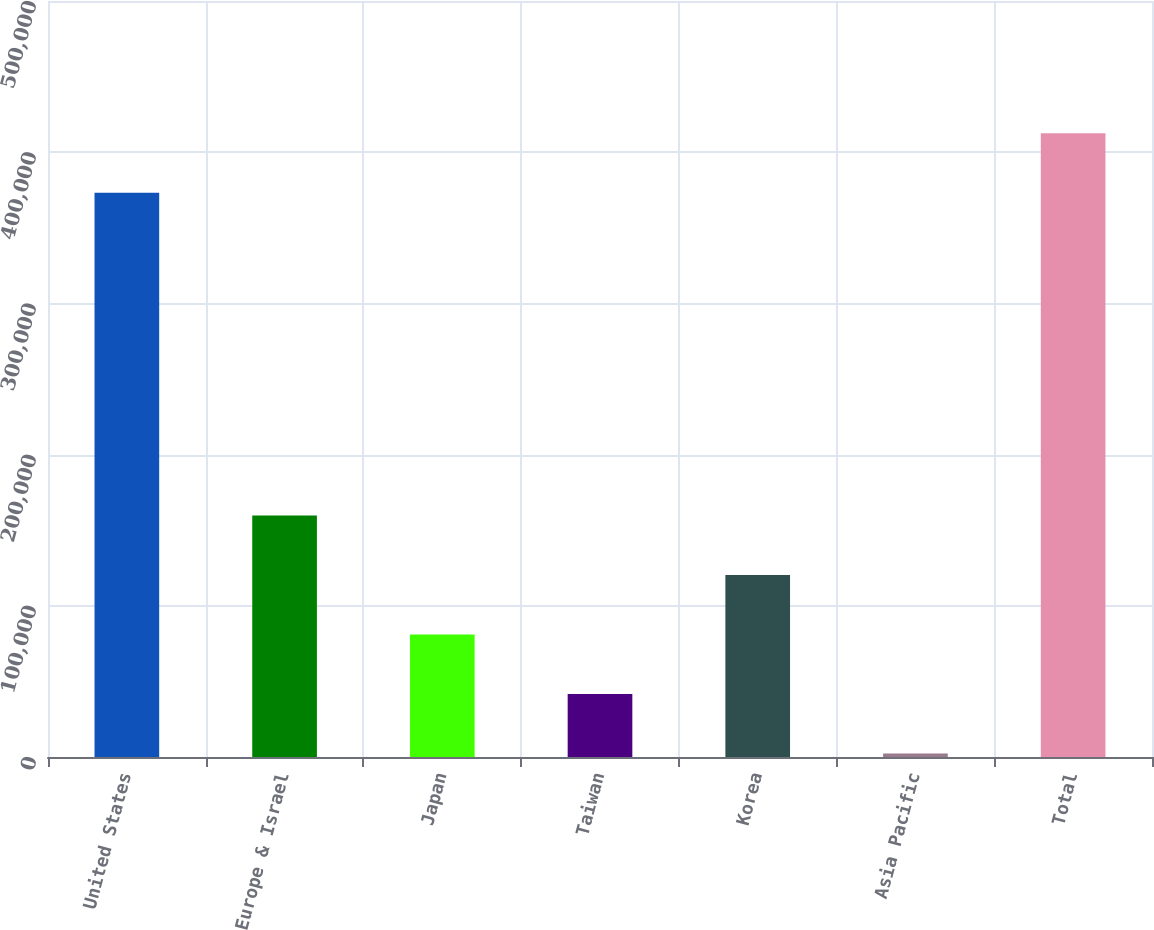Convert chart to OTSL. <chart><loc_0><loc_0><loc_500><loc_500><bar_chart><fcel>United States<fcel>Europe & Israel<fcel>Japan<fcel>Taiwan<fcel>Korea<fcel>Asia Pacific<fcel>Total<nl><fcel>373125<fcel>159748<fcel>80996.8<fcel>41621.4<fcel>120372<fcel>2246<fcel>412500<nl></chart> 